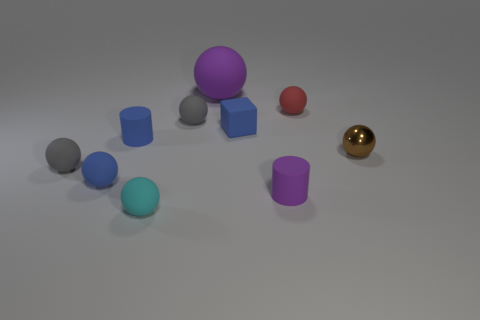What is the size of the matte cylinder that is the same color as the small cube?
Provide a short and direct response. Small. There is a tiny rubber object that is the same color as the large sphere; what is its shape?
Make the answer very short. Cylinder. Are there any other things that have the same material as the large purple sphere?
Give a very brief answer. Yes. How many large things are either metal spheres or gray rubber things?
Your answer should be very brief. 0. Is the shape of the purple matte thing in front of the large purple matte ball the same as  the tiny cyan rubber thing?
Give a very brief answer. No. Is the number of brown things less than the number of large cyan rubber cylinders?
Provide a succinct answer. No. Is there anything else of the same color as the tiny matte block?
Make the answer very short. Yes. What shape is the small gray thing behind the blue matte cube?
Your answer should be compact. Sphere. Do the small rubber cube and the rubber cylinder behind the brown metallic thing have the same color?
Your answer should be compact. Yes. Is the number of brown shiny balls on the left side of the cyan rubber ball the same as the number of tiny red matte spheres in front of the tiny brown metallic ball?
Ensure brevity in your answer.  Yes. 